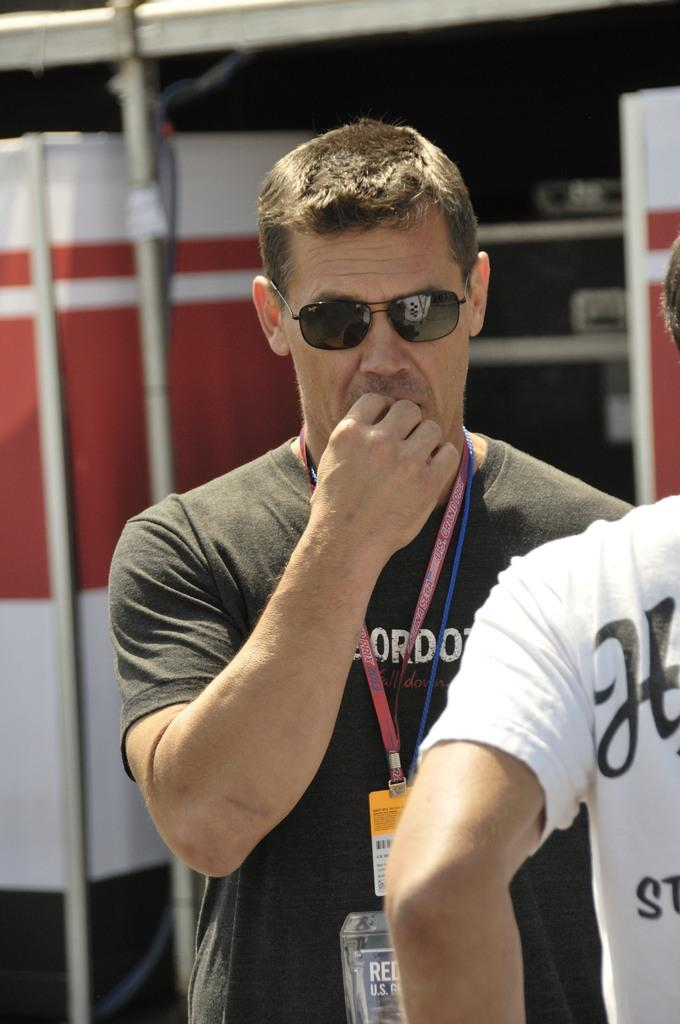<image>
Provide a brief description of the given image. A man in sunglasses wears a lanyard around his neck with the word PRIX on it. 